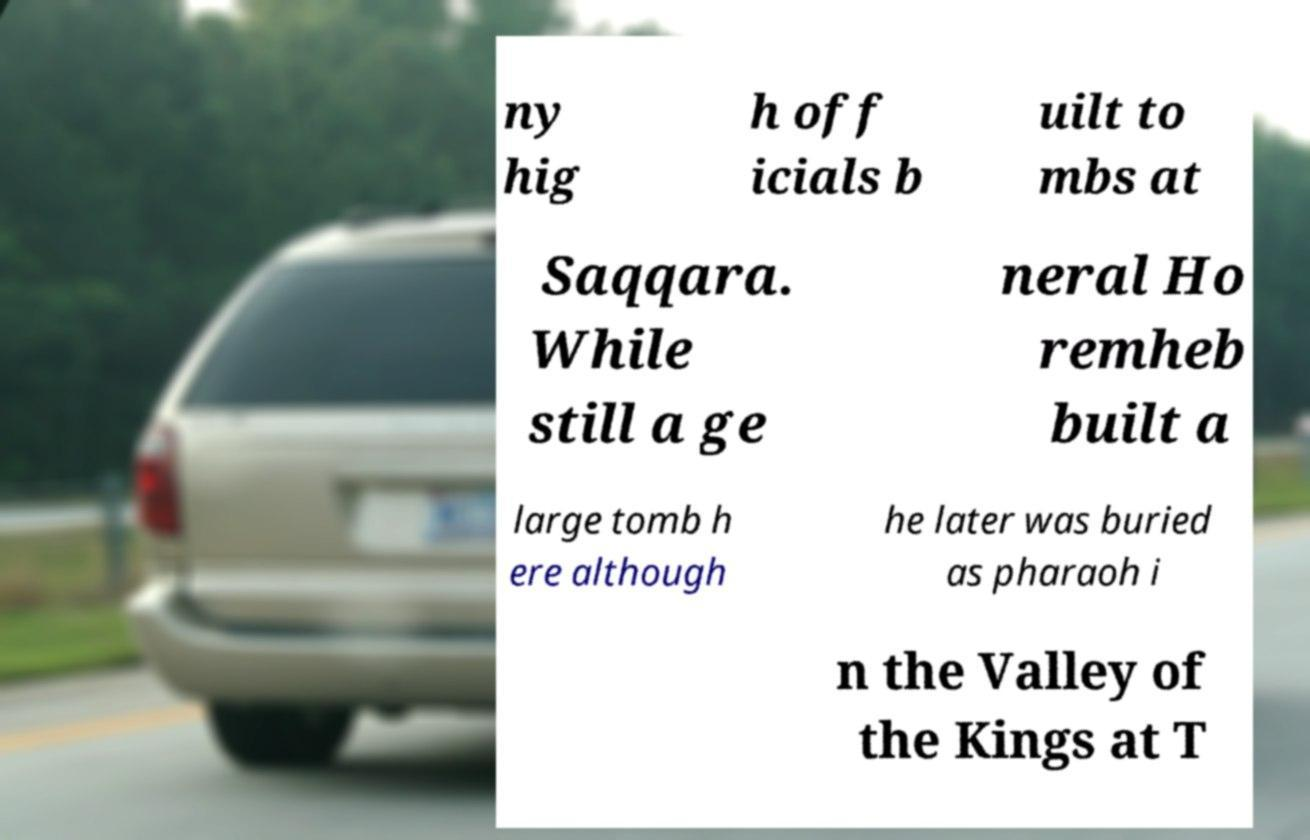Can you accurately transcribe the text from the provided image for me? ny hig h off icials b uilt to mbs at Saqqara. While still a ge neral Ho remheb built a large tomb h ere although he later was buried as pharaoh i n the Valley of the Kings at T 